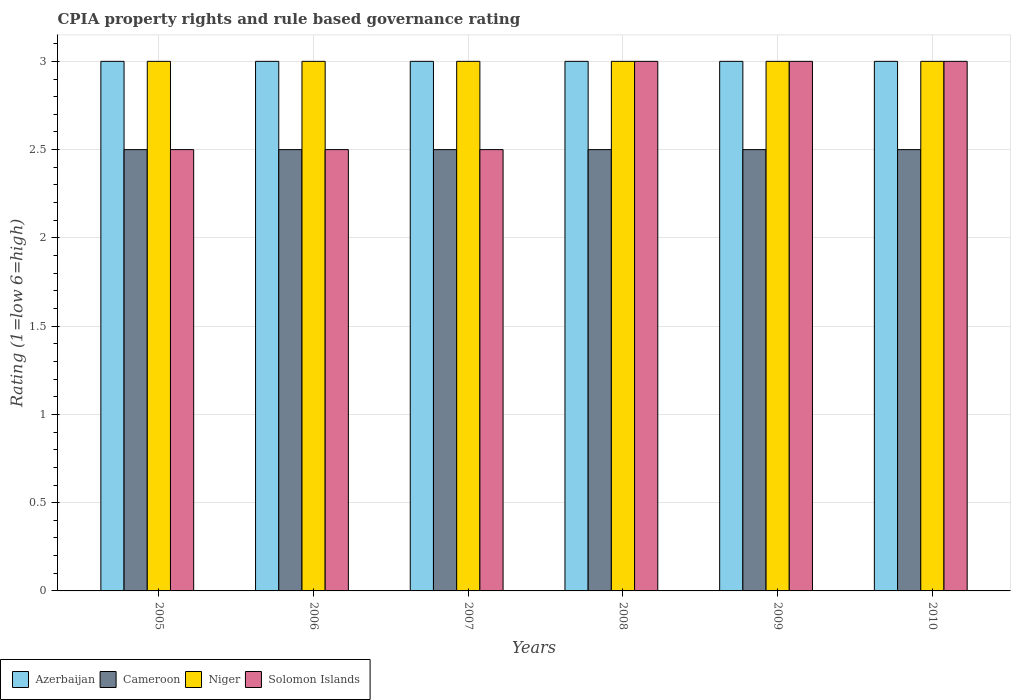How many groups of bars are there?
Your answer should be very brief. 6. Are the number of bars per tick equal to the number of legend labels?
Offer a very short reply. Yes. Are the number of bars on each tick of the X-axis equal?
Offer a very short reply. Yes. How many bars are there on the 3rd tick from the left?
Offer a terse response. 4. How many bars are there on the 1st tick from the right?
Your answer should be very brief. 4. What is the ratio of the CPIA rating in Niger in 2005 to that in 2008?
Your response must be concise. 1. Is the difference between the CPIA rating in Cameroon in 2006 and 2008 greater than the difference between the CPIA rating in Niger in 2006 and 2008?
Offer a terse response. No. What is the difference between the highest and the second highest CPIA rating in Cameroon?
Your response must be concise. 0. What is the difference between the highest and the lowest CPIA rating in Solomon Islands?
Your response must be concise. 0.5. In how many years, is the CPIA rating in Solomon Islands greater than the average CPIA rating in Solomon Islands taken over all years?
Provide a succinct answer. 3. Is it the case that in every year, the sum of the CPIA rating in Cameroon and CPIA rating in Azerbaijan is greater than the sum of CPIA rating in Niger and CPIA rating in Solomon Islands?
Keep it short and to the point. No. What does the 4th bar from the left in 2008 represents?
Your answer should be compact. Solomon Islands. What does the 3rd bar from the right in 2006 represents?
Offer a terse response. Cameroon. Is it the case that in every year, the sum of the CPIA rating in Cameroon and CPIA rating in Solomon Islands is greater than the CPIA rating in Niger?
Make the answer very short. Yes. Are all the bars in the graph horizontal?
Provide a succinct answer. No. What is the difference between two consecutive major ticks on the Y-axis?
Your response must be concise. 0.5. Does the graph contain any zero values?
Your answer should be compact. No. Does the graph contain grids?
Give a very brief answer. Yes. Where does the legend appear in the graph?
Your response must be concise. Bottom left. How many legend labels are there?
Your response must be concise. 4. How are the legend labels stacked?
Offer a very short reply. Horizontal. What is the title of the graph?
Ensure brevity in your answer.  CPIA property rights and rule based governance rating. What is the label or title of the X-axis?
Offer a terse response. Years. What is the Rating (1=low 6=high) of Azerbaijan in 2005?
Provide a succinct answer. 3. What is the Rating (1=low 6=high) of Cameroon in 2005?
Offer a very short reply. 2.5. What is the Rating (1=low 6=high) of Solomon Islands in 2005?
Your answer should be very brief. 2.5. What is the Rating (1=low 6=high) in Cameroon in 2006?
Provide a succinct answer. 2.5. What is the Rating (1=low 6=high) of Niger in 2006?
Provide a succinct answer. 3. What is the Rating (1=low 6=high) of Azerbaijan in 2007?
Offer a terse response. 3. What is the Rating (1=low 6=high) of Solomon Islands in 2007?
Keep it short and to the point. 2.5. What is the Rating (1=low 6=high) in Cameroon in 2008?
Your answer should be compact. 2.5. What is the Rating (1=low 6=high) of Solomon Islands in 2008?
Keep it short and to the point. 3. What is the Rating (1=low 6=high) in Azerbaijan in 2009?
Provide a succinct answer. 3. What is the Rating (1=low 6=high) in Cameroon in 2009?
Give a very brief answer. 2.5. What is the Rating (1=low 6=high) of Solomon Islands in 2009?
Provide a succinct answer. 3. What is the Rating (1=low 6=high) of Niger in 2010?
Your response must be concise. 3. Across all years, what is the minimum Rating (1=low 6=high) in Cameroon?
Your answer should be compact. 2.5. Across all years, what is the minimum Rating (1=low 6=high) of Solomon Islands?
Keep it short and to the point. 2.5. What is the total Rating (1=low 6=high) in Cameroon in the graph?
Your answer should be compact. 15. What is the total Rating (1=low 6=high) in Niger in the graph?
Your response must be concise. 18. What is the difference between the Rating (1=low 6=high) in Azerbaijan in 2005 and that in 2006?
Your response must be concise. 0. What is the difference between the Rating (1=low 6=high) in Cameroon in 2005 and that in 2007?
Offer a very short reply. 0. What is the difference between the Rating (1=low 6=high) in Niger in 2005 and that in 2007?
Give a very brief answer. 0. What is the difference between the Rating (1=low 6=high) of Azerbaijan in 2005 and that in 2008?
Offer a very short reply. 0. What is the difference between the Rating (1=low 6=high) in Niger in 2005 and that in 2008?
Your answer should be very brief. 0. What is the difference between the Rating (1=low 6=high) in Cameroon in 2005 and that in 2010?
Ensure brevity in your answer.  0. What is the difference between the Rating (1=low 6=high) in Niger in 2005 and that in 2010?
Your answer should be compact. 0. What is the difference between the Rating (1=low 6=high) in Azerbaijan in 2006 and that in 2007?
Ensure brevity in your answer.  0. What is the difference between the Rating (1=low 6=high) of Cameroon in 2006 and that in 2007?
Offer a very short reply. 0. What is the difference between the Rating (1=low 6=high) in Niger in 2006 and that in 2007?
Your response must be concise. 0. What is the difference between the Rating (1=low 6=high) in Solomon Islands in 2006 and that in 2007?
Your answer should be compact. 0. What is the difference between the Rating (1=low 6=high) of Azerbaijan in 2006 and that in 2008?
Make the answer very short. 0. What is the difference between the Rating (1=low 6=high) in Cameroon in 2006 and that in 2008?
Give a very brief answer. 0. What is the difference between the Rating (1=low 6=high) of Solomon Islands in 2006 and that in 2009?
Offer a terse response. -0.5. What is the difference between the Rating (1=low 6=high) in Azerbaijan in 2006 and that in 2010?
Offer a very short reply. 0. What is the difference between the Rating (1=low 6=high) of Cameroon in 2006 and that in 2010?
Your answer should be very brief. 0. What is the difference between the Rating (1=low 6=high) of Solomon Islands in 2006 and that in 2010?
Give a very brief answer. -0.5. What is the difference between the Rating (1=low 6=high) of Niger in 2007 and that in 2008?
Offer a very short reply. 0. What is the difference between the Rating (1=low 6=high) of Solomon Islands in 2007 and that in 2008?
Ensure brevity in your answer.  -0.5. What is the difference between the Rating (1=low 6=high) of Niger in 2007 and that in 2009?
Offer a very short reply. 0. What is the difference between the Rating (1=low 6=high) in Cameroon in 2007 and that in 2010?
Ensure brevity in your answer.  0. What is the difference between the Rating (1=low 6=high) of Niger in 2008 and that in 2009?
Make the answer very short. 0. What is the difference between the Rating (1=low 6=high) of Azerbaijan in 2008 and that in 2010?
Your answer should be very brief. 0. What is the difference between the Rating (1=low 6=high) of Cameroon in 2009 and that in 2010?
Provide a short and direct response. 0. What is the difference between the Rating (1=low 6=high) in Azerbaijan in 2005 and the Rating (1=low 6=high) in Cameroon in 2006?
Give a very brief answer. 0.5. What is the difference between the Rating (1=low 6=high) of Azerbaijan in 2005 and the Rating (1=low 6=high) of Niger in 2006?
Provide a short and direct response. 0. What is the difference between the Rating (1=low 6=high) of Azerbaijan in 2005 and the Rating (1=low 6=high) of Solomon Islands in 2006?
Ensure brevity in your answer.  0.5. What is the difference between the Rating (1=low 6=high) in Cameroon in 2005 and the Rating (1=low 6=high) in Solomon Islands in 2006?
Your response must be concise. 0. What is the difference between the Rating (1=low 6=high) of Niger in 2005 and the Rating (1=low 6=high) of Solomon Islands in 2006?
Give a very brief answer. 0.5. What is the difference between the Rating (1=low 6=high) of Azerbaijan in 2005 and the Rating (1=low 6=high) of Cameroon in 2007?
Offer a terse response. 0.5. What is the difference between the Rating (1=low 6=high) of Azerbaijan in 2005 and the Rating (1=low 6=high) of Solomon Islands in 2007?
Ensure brevity in your answer.  0.5. What is the difference between the Rating (1=low 6=high) of Cameroon in 2005 and the Rating (1=low 6=high) of Solomon Islands in 2007?
Provide a succinct answer. 0. What is the difference between the Rating (1=low 6=high) of Niger in 2005 and the Rating (1=low 6=high) of Solomon Islands in 2007?
Your answer should be very brief. 0.5. What is the difference between the Rating (1=low 6=high) of Azerbaijan in 2005 and the Rating (1=low 6=high) of Solomon Islands in 2008?
Your answer should be very brief. 0. What is the difference between the Rating (1=low 6=high) in Cameroon in 2005 and the Rating (1=low 6=high) in Niger in 2008?
Ensure brevity in your answer.  -0.5. What is the difference between the Rating (1=low 6=high) of Cameroon in 2005 and the Rating (1=low 6=high) of Solomon Islands in 2008?
Make the answer very short. -0.5. What is the difference between the Rating (1=low 6=high) in Niger in 2005 and the Rating (1=low 6=high) in Solomon Islands in 2008?
Provide a short and direct response. 0. What is the difference between the Rating (1=low 6=high) in Azerbaijan in 2005 and the Rating (1=low 6=high) in Cameroon in 2009?
Your answer should be very brief. 0.5. What is the difference between the Rating (1=low 6=high) of Cameroon in 2005 and the Rating (1=low 6=high) of Solomon Islands in 2009?
Make the answer very short. -0.5. What is the difference between the Rating (1=low 6=high) of Azerbaijan in 2005 and the Rating (1=low 6=high) of Cameroon in 2010?
Give a very brief answer. 0.5. What is the difference between the Rating (1=low 6=high) in Azerbaijan in 2005 and the Rating (1=low 6=high) in Niger in 2010?
Ensure brevity in your answer.  0. What is the difference between the Rating (1=low 6=high) in Cameroon in 2005 and the Rating (1=low 6=high) in Niger in 2010?
Make the answer very short. -0.5. What is the difference between the Rating (1=low 6=high) of Niger in 2005 and the Rating (1=low 6=high) of Solomon Islands in 2010?
Ensure brevity in your answer.  0. What is the difference between the Rating (1=low 6=high) in Azerbaijan in 2006 and the Rating (1=low 6=high) in Cameroon in 2007?
Keep it short and to the point. 0.5. What is the difference between the Rating (1=low 6=high) of Azerbaijan in 2006 and the Rating (1=low 6=high) of Solomon Islands in 2007?
Offer a very short reply. 0.5. What is the difference between the Rating (1=low 6=high) in Cameroon in 2006 and the Rating (1=low 6=high) in Niger in 2007?
Give a very brief answer. -0.5. What is the difference between the Rating (1=low 6=high) of Azerbaijan in 2006 and the Rating (1=low 6=high) of Cameroon in 2008?
Your answer should be very brief. 0.5. What is the difference between the Rating (1=low 6=high) of Azerbaijan in 2006 and the Rating (1=low 6=high) of Solomon Islands in 2008?
Your response must be concise. 0. What is the difference between the Rating (1=low 6=high) in Cameroon in 2006 and the Rating (1=low 6=high) in Niger in 2008?
Provide a short and direct response. -0.5. What is the difference between the Rating (1=low 6=high) in Cameroon in 2006 and the Rating (1=low 6=high) in Solomon Islands in 2008?
Provide a succinct answer. -0.5. What is the difference between the Rating (1=low 6=high) in Azerbaijan in 2006 and the Rating (1=low 6=high) in Cameroon in 2009?
Your answer should be very brief. 0.5. What is the difference between the Rating (1=low 6=high) in Azerbaijan in 2006 and the Rating (1=low 6=high) in Niger in 2009?
Your answer should be compact. 0. What is the difference between the Rating (1=low 6=high) of Azerbaijan in 2006 and the Rating (1=low 6=high) of Solomon Islands in 2009?
Keep it short and to the point. 0. What is the difference between the Rating (1=low 6=high) of Cameroon in 2006 and the Rating (1=low 6=high) of Niger in 2009?
Provide a short and direct response. -0.5. What is the difference between the Rating (1=low 6=high) of Cameroon in 2006 and the Rating (1=low 6=high) of Solomon Islands in 2009?
Provide a short and direct response. -0.5. What is the difference between the Rating (1=low 6=high) in Cameroon in 2006 and the Rating (1=low 6=high) in Niger in 2010?
Offer a very short reply. -0.5. What is the difference between the Rating (1=low 6=high) in Azerbaijan in 2007 and the Rating (1=low 6=high) in Cameroon in 2008?
Your response must be concise. 0.5. What is the difference between the Rating (1=low 6=high) in Azerbaijan in 2007 and the Rating (1=low 6=high) in Niger in 2008?
Offer a very short reply. 0. What is the difference between the Rating (1=low 6=high) in Azerbaijan in 2007 and the Rating (1=low 6=high) in Solomon Islands in 2008?
Make the answer very short. 0. What is the difference between the Rating (1=low 6=high) of Cameroon in 2007 and the Rating (1=low 6=high) of Solomon Islands in 2008?
Offer a terse response. -0.5. What is the difference between the Rating (1=low 6=high) of Niger in 2007 and the Rating (1=low 6=high) of Solomon Islands in 2008?
Your response must be concise. 0. What is the difference between the Rating (1=low 6=high) in Azerbaijan in 2007 and the Rating (1=low 6=high) in Cameroon in 2009?
Make the answer very short. 0.5. What is the difference between the Rating (1=low 6=high) of Azerbaijan in 2007 and the Rating (1=low 6=high) of Niger in 2009?
Provide a short and direct response. 0. What is the difference between the Rating (1=low 6=high) of Cameroon in 2007 and the Rating (1=low 6=high) of Niger in 2009?
Your answer should be compact. -0.5. What is the difference between the Rating (1=low 6=high) in Cameroon in 2007 and the Rating (1=low 6=high) in Solomon Islands in 2009?
Your answer should be very brief. -0.5. What is the difference between the Rating (1=low 6=high) of Niger in 2007 and the Rating (1=low 6=high) of Solomon Islands in 2009?
Keep it short and to the point. 0. What is the difference between the Rating (1=low 6=high) in Azerbaijan in 2007 and the Rating (1=low 6=high) in Niger in 2010?
Provide a short and direct response. 0. What is the difference between the Rating (1=low 6=high) of Niger in 2007 and the Rating (1=low 6=high) of Solomon Islands in 2010?
Provide a short and direct response. 0. What is the difference between the Rating (1=low 6=high) in Azerbaijan in 2008 and the Rating (1=low 6=high) in Cameroon in 2009?
Your answer should be very brief. 0.5. What is the difference between the Rating (1=low 6=high) in Azerbaijan in 2008 and the Rating (1=low 6=high) in Niger in 2009?
Ensure brevity in your answer.  0. What is the difference between the Rating (1=low 6=high) of Cameroon in 2008 and the Rating (1=low 6=high) of Niger in 2009?
Provide a succinct answer. -0.5. What is the difference between the Rating (1=low 6=high) in Niger in 2008 and the Rating (1=low 6=high) in Solomon Islands in 2009?
Your answer should be compact. 0. What is the difference between the Rating (1=low 6=high) of Azerbaijan in 2008 and the Rating (1=low 6=high) of Niger in 2010?
Your answer should be very brief. 0. What is the difference between the Rating (1=low 6=high) in Azerbaijan in 2009 and the Rating (1=low 6=high) in Niger in 2010?
Keep it short and to the point. 0. What is the difference between the Rating (1=low 6=high) in Azerbaijan in 2009 and the Rating (1=low 6=high) in Solomon Islands in 2010?
Make the answer very short. 0. What is the difference between the Rating (1=low 6=high) of Niger in 2009 and the Rating (1=low 6=high) of Solomon Islands in 2010?
Your answer should be compact. 0. What is the average Rating (1=low 6=high) in Azerbaijan per year?
Provide a short and direct response. 3. What is the average Rating (1=low 6=high) of Solomon Islands per year?
Ensure brevity in your answer.  2.75. In the year 2005, what is the difference between the Rating (1=low 6=high) of Azerbaijan and Rating (1=low 6=high) of Cameroon?
Your answer should be very brief. 0.5. In the year 2005, what is the difference between the Rating (1=low 6=high) of Azerbaijan and Rating (1=low 6=high) of Niger?
Provide a succinct answer. 0. In the year 2005, what is the difference between the Rating (1=low 6=high) of Cameroon and Rating (1=low 6=high) of Niger?
Ensure brevity in your answer.  -0.5. In the year 2005, what is the difference between the Rating (1=low 6=high) of Niger and Rating (1=low 6=high) of Solomon Islands?
Ensure brevity in your answer.  0.5. In the year 2006, what is the difference between the Rating (1=low 6=high) in Azerbaijan and Rating (1=low 6=high) in Cameroon?
Give a very brief answer. 0.5. In the year 2006, what is the difference between the Rating (1=low 6=high) in Azerbaijan and Rating (1=low 6=high) in Niger?
Offer a very short reply. 0. In the year 2006, what is the difference between the Rating (1=low 6=high) of Azerbaijan and Rating (1=low 6=high) of Solomon Islands?
Provide a succinct answer. 0.5. In the year 2006, what is the difference between the Rating (1=low 6=high) in Cameroon and Rating (1=low 6=high) in Niger?
Your answer should be compact. -0.5. In the year 2007, what is the difference between the Rating (1=low 6=high) of Azerbaijan and Rating (1=low 6=high) of Cameroon?
Your response must be concise. 0.5. In the year 2007, what is the difference between the Rating (1=low 6=high) of Azerbaijan and Rating (1=low 6=high) of Niger?
Provide a succinct answer. 0. In the year 2007, what is the difference between the Rating (1=low 6=high) of Azerbaijan and Rating (1=low 6=high) of Solomon Islands?
Make the answer very short. 0.5. In the year 2007, what is the difference between the Rating (1=low 6=high) of Cameroon and Rating (1=low 6=high) of Solomon Islands?
Your answer should be compact. 0. In the year 2007, what is the difference between the Rating (1=low 6=high) of Niger and Rating (1=low 6=high) of Solomon Islands?
Your response must be concise. 0.5. In the year 2008, what is the difference between the Rating (1=low 6=high) in Cameroon and Rating (1=low 6=high) in Solomon Islands?
Make the answer very short. -0.5. In the year 2008, what is the difference between the Rating (1=low 6=high) of Niger and Rating (1=low 6=high) of Solomon Islands?
Your answer should be compact. 0. In the year 2009, what is the difference between the Rating (1=low 6=high) in Azerbaijan and Rating (1=low 6=high) in Cameroon?
Make the answer very short. 0.5. In the year 2009, what is the difference between the Rating (1=low 6=high) in Azerbaijan and Rating (1=low 6=high) in Niger?
Your answer should be very brief. 0. In the year 2009, what is the difference between the Rating (1=low 6=high) of Azerbaijan and Rating (1=low 6=high) of Solomon Islands?
Offer a very short reply. 0. In the year 2009, what is the difference between the Rating (1=low 6=high) of Cameroon and Rating (1=low 6=high) of Niger?
Give a very brief answer. -0.5. In the year 2009, what is the difference between the Rating (1=low 6=high) in Cameroon and Rating (1=low 6=high) in Solomon Islands?
Provide a succinct answer. -0.5. In the year 2010, what is the difference between the Rating (1=low 6=high) in Azerbaijan and Rating (1=low 6=high) in Cameroon?
Your response must be concise. 0.5. In the year 2010, what is the difference between the Rating (1=low 6=high) in Cameroon and Rating (1=low 6=high) in Niger?
Provide a succinct answer. -0.5. In the year 2010, what is the difference between the Rating (1=low 6=high) of Niger and Rating (1=low 6=high) of Solomon Islands?
Make the answer very short. 0. What is the ratio of the Rating (1=low 6=high) of Niger in 2005 to that in 2007?
Offer a very short reply. 1. What is the ratio of the Rating (1=low 6=high) in Solomon Islands in 2005 to that in 2007?
Offer a very short reply. 1. What is the ratio of the Rating (1=low 6=high) in Azerbaijan in 2005 to that in 2008?
Offer a very short reply. 1. What is the ratio of the Rating (1=low 6=high) in Cameroon in 2005 to that in 2009?
Offer a very short reply. 1. What is the ratio of the Rating (1=low 6=high) of Niger in 2005 to that in 2010?
Make the answer very short. 1. What is the ratio of the Rating (1=low 6=high) in Solomon Islands in 2005 to that in 2010?
Ensure brevity in your answer.  0.83. What is the ratio of the Rating (1=low 6=high) of Niger in 2006 to that in 2007?
Offer a very short reply. 1. What is the ratio of the Rating (1=low 6=high) in Solomon Islands in 2006 to that in 2007?
Make the answer very short. 1. What is the ratio of the Rating (1=low 6=high) in Niger in 2006 to that in 2008?
Offer a terse response. 1. What is the ratio of the Rating (1=low 6=high) in Cameroon in 2006 to that in 2009?
Offer a very short reply. 1. What is the ratio of the Rating (1=low 6=high) in Niger in 2006 to that in 2009?
Make the answer very short. 1. What is the ratio of the Rating (1=low 6=high) of Niger in 2006 to that in 2010?
Offer a terse response. 1. What is the ratio of the Rating (1=low 6=high) of Azerbaijan in 2007 to that in 2008?
Your response must be concise. 1. What is the ratio of the Rating (1=low 6=high) of Cameroon in 2007 to that in 2008?
Your response must be concise. 1. What is the ratio of the Rating (1=low 6=high) in Solomon Islands in 2007 to that in 2008?
Your response must be concise. 0.83. What is the ratio of the Rating (1=low 6=high) of Cameroon in 2007 to that in 2009?
Keep it short and to the point. 1. What is the ratio of the Rating (1=low 6=high) in Niger in 2007 to that in 2010?
Offer a very short reply. 1. What is the ratio of the Rating (1=low 6=high) of Solomon Islands in 2007 to that in 2010?
Provide a succinct answer. 0.83. What is the ratio of the Rating (1=low 6=high) in Azerbaijan in 2008 to that in 2009?
Provide a succinct answer. 1. What is the ratio of the Rating (1=low 6=high) in Niger in 2008 to that in 2009?
Your answer should be very brief. 1. What is the ratio of the Rating (1=low 6=high) of Solomon Islands in 2008 to that in 2009?
Offer a terse response. 1. What is the ratio of the Rating (1=low 6=high) in Azerbaijan in 2008 to that in 2010?
Your answer should be very brief. 1. What is the ratio of the Rating (1=low 6=high) in Cameroon in 2008 to that in 2010?
Provide a succinct answer. 1. What is the ratio of the Rating (1=low 6=high) of Niger in 2008 to that in 2010?
Your response must be concise. 1. What is the ratio of the Rating (1=low 6=high) in Solomon Islands in 2008 to that in 2010?
Your response must be concise. 1. What is the ratio of the Rating (1=low 6=high) in Cameroon in 2009 to that in 2010?
Your response must be concise. 1. What is the ratio of the Rating (1=low 6=high) of Niger in 2009 to that in 2010?
Your answer should be compact. 1. What is the difference between the highest and the lowest Rating (1=low 6=high) of Azerbaijan?
Your answer should be compact. 0. What is the difference between the highest and the lowest Rating (1=low 6=high) of Niger?
Ensure brevity in your answer.  0. What is the difference between the highest and the lowest Rating (1=low 6=high) of Solomon Islands?
Provide a short and direct response. 0.5. 